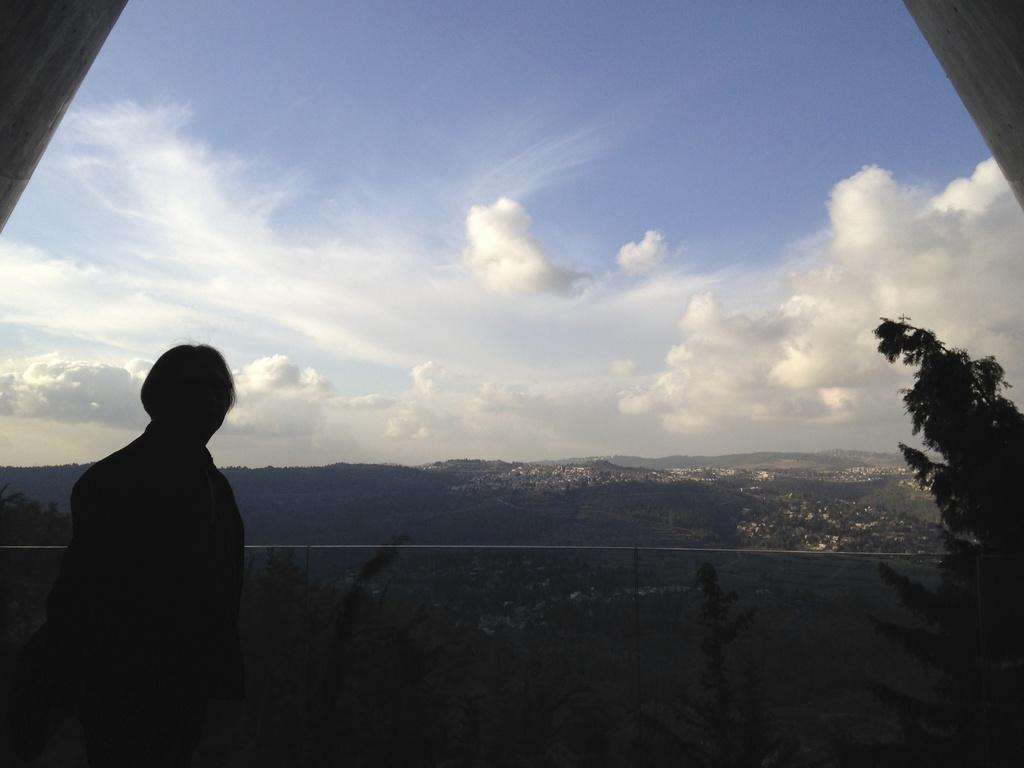What is the person in the image doing? The person is standing at the balcony. What can be seen in the background of the image? There are buildings, trees, and the sky visible in the background of the image. How many lizards are crawling on the stem in the image? There are no lizards or stems present in the image. What does the caption say about the person standing at the balcony? There is no caption provided with the image, so we cannot determine what it might say about the person standing at the balcony. 